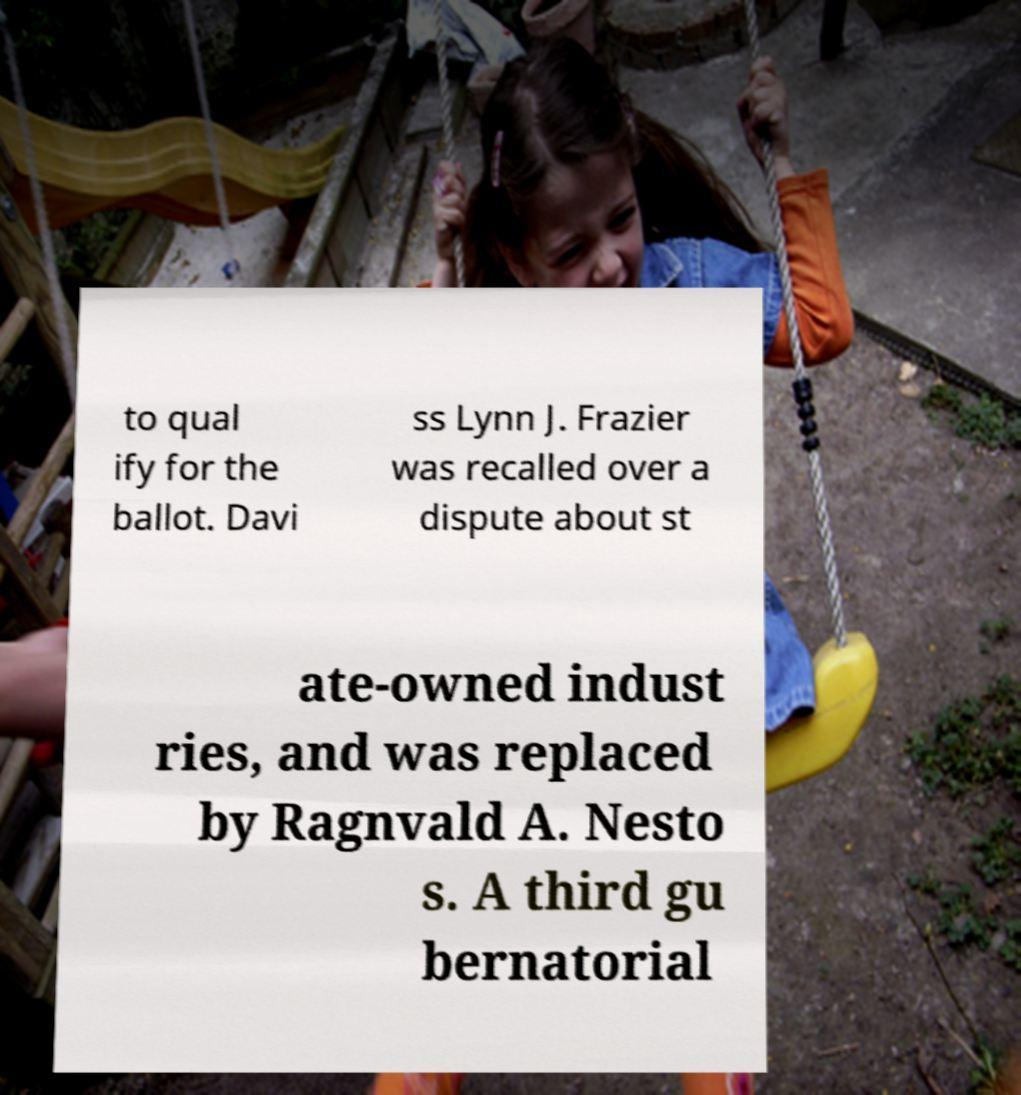Please identify and transcribe the text found in this image. to qual ify for the ballot. Davi ss Lynn J. Frazier was recalled over a dispute about st ate-owned indust ries, and was replaced by Ragnvald A. Nesto s. A third gu bernatorial 